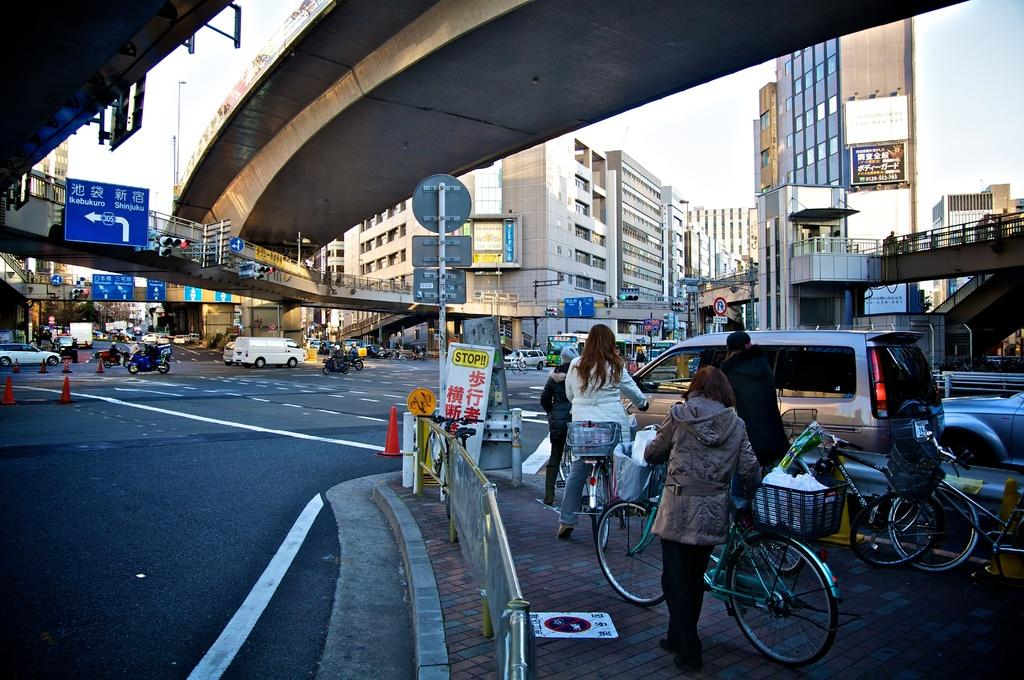What type of view is depicted in the image? The image contains a road view. What vehicles can be seen on the road? There are cars in the image. Are there any other modes of transportation visible? Yes, there are bikes in the image. What structures are present above the road? There are bridges above the road in the image. What type of surroundings can be seen around the road? There are buildings around the area in the image. What type of grain is being harvested in the image? There is no grain present in the image; it contains a road view with cars, bikes, bridges, and buildings. 